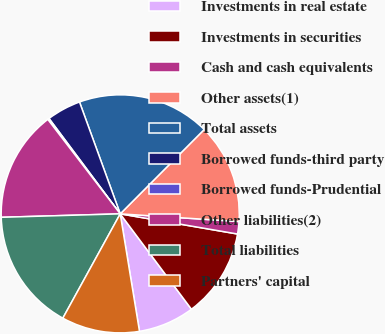Convert chart to OTSL. <chart><loc_0><loc_0><loc_500><loc_500><pie_chart><fcel>Investments in real estate<fcel>Investments in securities<fcel>Cash and cash equivalents<fcel>Other assets(1)<fcel>Total assets<fcel>Borrowed funds-third party<fcel>Borrowed funds-Prudential<fcel>Other liabilities(2)<fcel>Total liabilities<fcel>Partners' capital<nl><fcel>7.62%<fcel>12.08%<fcel>1.68%<fcel>13.56%<fcel>18.02%<fcel>4.65%<fcel>0.2%<fcel>15.05%<fcel>16.53%<fcel>10.59%<nl></chart> 